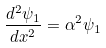<formula> <loc_0><loc_0><loc_500><loc_500>\frac { d ^ { 2 } \psi _ { 1 } } { d x ^ { 2 } } = \alpha ^ { 2 } \psi _ { 1 }</formula> 